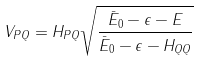<formula> <loc_0><loc_0><loc_500><loc_500>V _ { P Q } = H _ { P Q } \sqrt { \frac { \bar { E } _ { 0 } - \epsilon - E } { \bar { E } _ { 0 } - \epsilon - H _ { Q Q } } }</formula> 